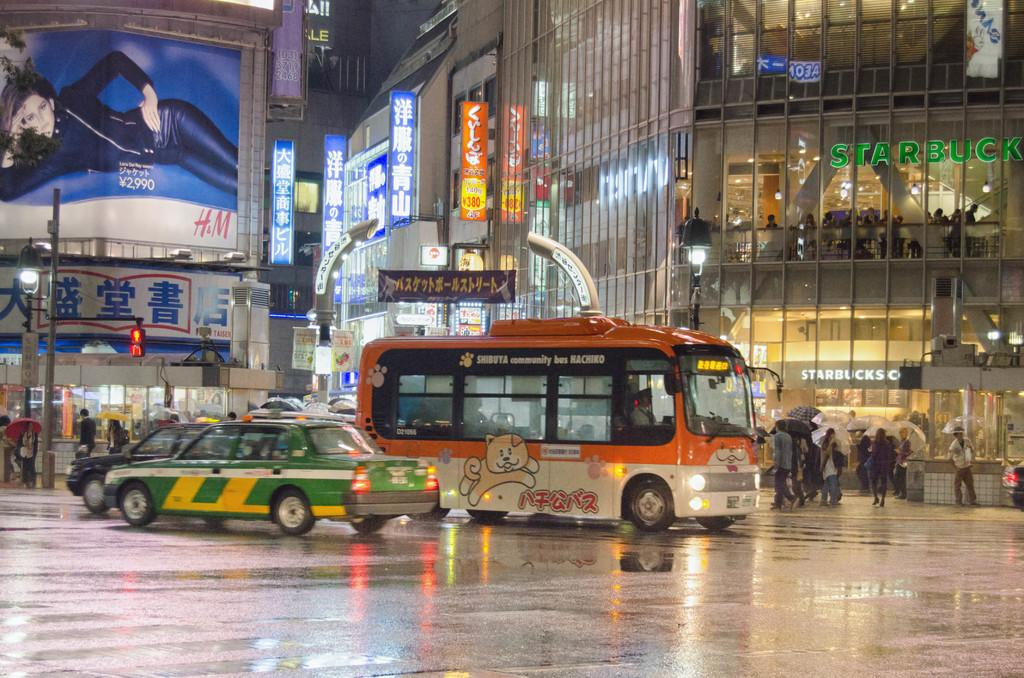<image>
Summarize the visual content of the image. The Shibuya community bus is passing in front of a Starbucks store. 